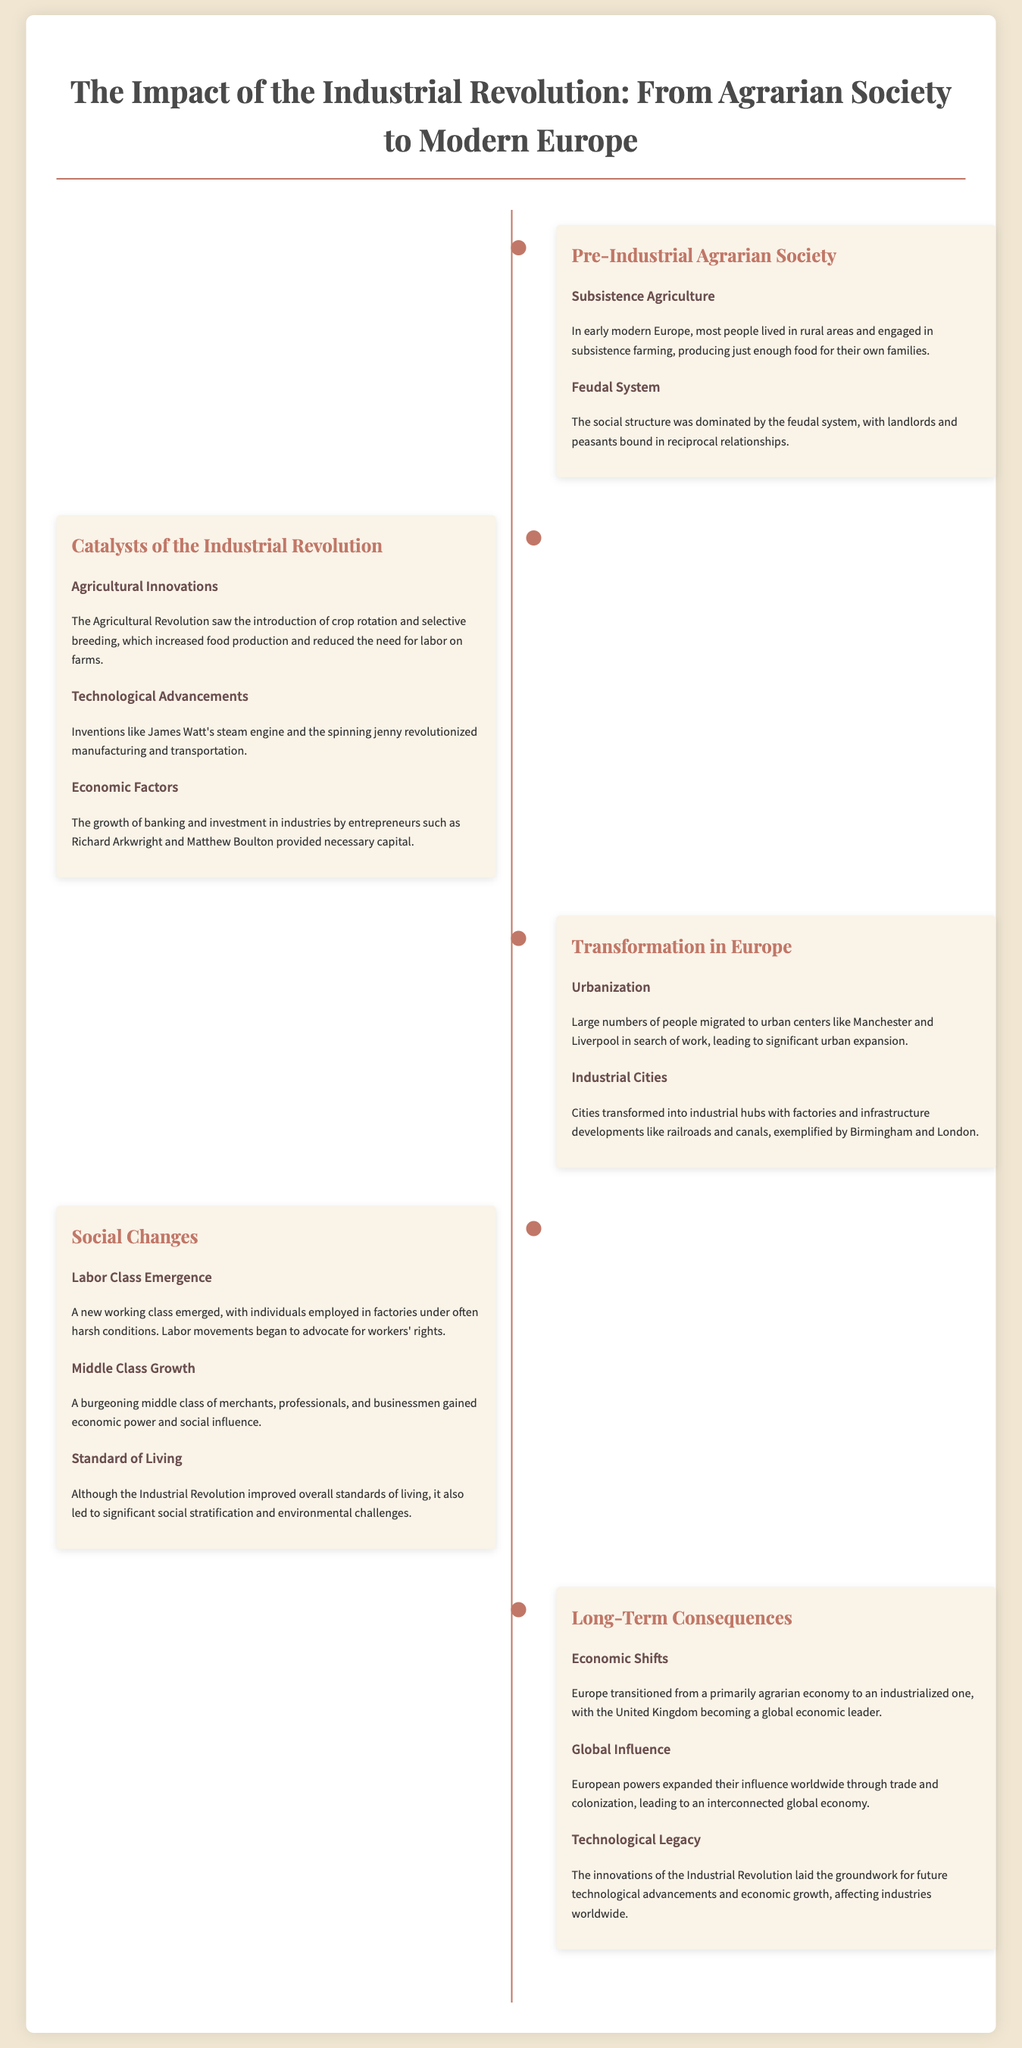What farming method dominated early modern Europe? The document states that most people engaged in subsistence farming, producing just enough food for their own families.
Answer: Subsistence farming What invention is attributed to James Watt? The text notes that James Watt's steam engine was a significant technological advancement during the Industrial Revolution.
Answer: Steam engine What led to urban expansion during the Industrial Revolution? The document mentions that large numbers of people migrated to urban centers in search of work.
Answer: Migration What was the social structure in pre-industrial Europe? According to the document, the social structure was dominated by the feudal system.
Answer: Feudal system Which two industrial cities are mentioned as examples? The timeline highlights Birmingham and London as transformed industrial hubs.
Answer: Birmingham and London What class emerged due to industrialization? The document notes that a new working class emerged, employed in factories.
Answer: Working class What significant economic transition occurred in Europe? The document states that Europe transitioned from a primarily agrarian economy to an industrialized one.
Answer: Industrialized economy Which period saw the introduction of crop rotation? The Agricultural Revolution is identified as the period when crop rotation and selective breeding were introduced.
Answer: Agricultural Revolution How did the Industrial Revolution affect the standard of living? Despite improvements, the document mentions significant social stratification and environmental challenges.
Answer: Social stratification and environmental challenges 